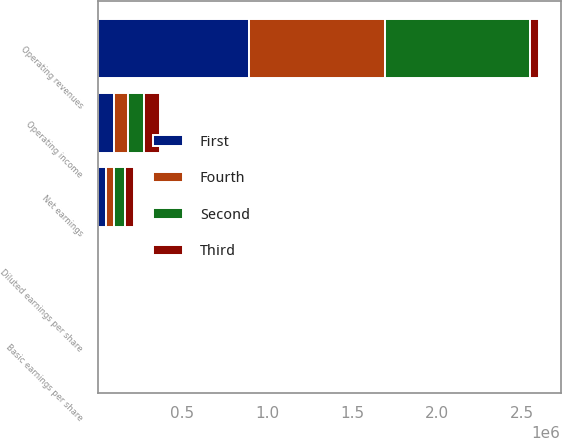<chart> <loc_0><loc_0><loc_500><loc_500><stacked_bar_chart><ecel><fcel>Operating revenues<fcel>Operating income<fcel>Net earnings<fcel>Basic earnings per share<fcel>Diluted earnings per share<nl><fcel>Fourth<fcel>797451<fcel>80399<fcel>44170<fcel>0.31<fcel>0.3<nl><fcel>Second<fcel>855860<fcel>96227<fcel>63857<fcel>0.46<fcel>0.45<nl><fcel>First<fcel>891638<fcel>95899<fcel>50783<fcel>0.39<fcel>0.38<nl><fcel>Third<fcel>50783<fcel>96265<fcel>54323<fcel>0.43<fcel>0.42<nl></chart> 